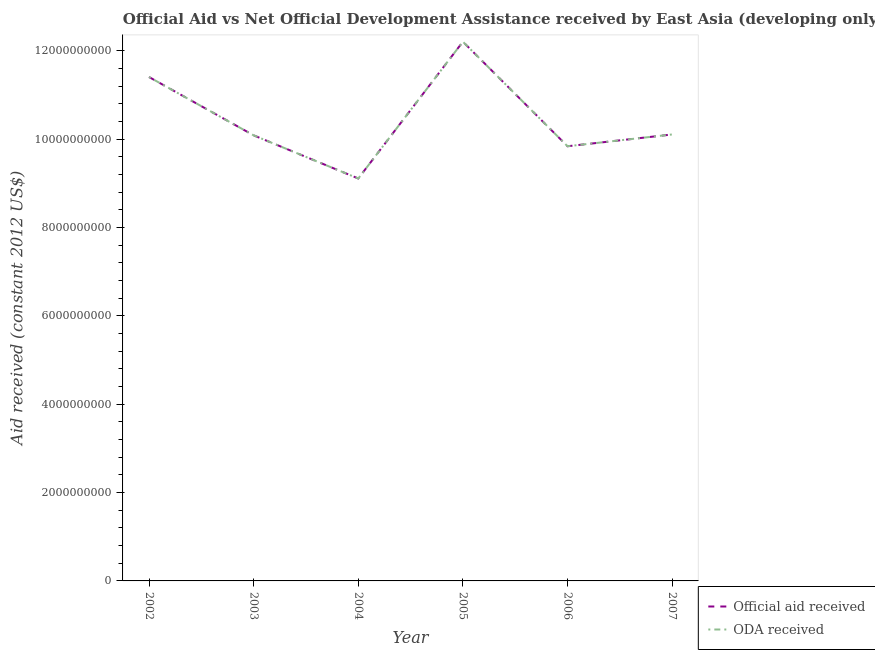How many different coloured lines are there?
Offer a terse response. 2. What is the oda received in 2005?
Ensure brevity in your answer.  1.22e+1. Across all years, what is the maximum official aid received?
Offer a terse response. 1.22e+1. Across all years, what is the minimum oda received?
Make the answer very short. 9.11e+09. What is the total oda received in the graph?
Provide a short and direct response. 6.28e+1. What is the difference between the oda received in 2004 and that in 2007?
Provide a succinct answer. -9.97e+08. What is the difference between the official aid received in 2003 and the oda received in 2004?
Make the answer very short. 9.77e+08. What is the average oda received per year?
Provide a short and direct response. 1.05e+1. In the year 2003, what is the difference between the oda received and official aid received?
Give a very brief answer. 0. What is the ratio of the official aid received in 2005 to that in 2007?
Ensure brevity in your answer.  1.21. Is the difference between the official aid received in 2003 and 2007 greater than the difference between the oda received in 2003 and 2007?
Offer a very short reply. No. What is the difference between the highest and the second highest oda received?
Provide a succinct answer. 7.99e+08. What is the difference between the highest and the lowest oda received?
Provide a succinct answer. 3.10e+09. In how many years, is the oda received greater than the average oda received taken over all years?
Your response must be concise. 2. Is the sum of the official aid received in 2003 and 2004 greater than the maximum oda received across all years?
Make the answer very short. Yes. Is the official aid received strictly greater than the oda received over the years?
Your answer should be very brief. No. How many years are there in the graph?
Ensure brevity in your answer.  6. Are the values on the major ticks of Y-axis written in scientific E-notation?
Your answer should be compact. No. Does the graph contain any zero values?
Make the answer very short. No. Does the graph contain grids?
Provide a succinct answer. No. How are the legend labels stacked?
Your response must be concise. Vertical. What is the title of the graph?
Your answer should be very brief. Official Aid vs Net Official Development Assistance received by East Asia (developing only) . Does "Lower secondary rate" appear as one of the legend labels in the graph?
Give a very brief answer. No. What is the label or title of the Y-axis?
Ensure brevity in your answer.  Aid received (constant 2012 US$). What is the Aid received (constant 2012 US$) of Official aid received in 2002?
Make the answer very short. 1.14e+1. What is the Aid received (constant 2012 US$) in ODA received in 2002?
Ensure brevity in your answer.  1.14e+1. What is the Aid received (constant 2012 US$) of Official aid received in 2003?
Your answer should be very brief. 1.01e+1. What is the Aid received (constant 2012 US$) in ODA received in 2003?
Offer a very short reply. 1.01e+1. What is the Aid received (constant 2012 US$) in Official aid received in 2004?
Provide a succinct answer. 9.11e+09. What is the Aid received (constant 2012 US$) of ODA received in 2004?
Your response must be concise. 9.11e+09. What is the Aid received (constant 2012 US$) in Official aid received in 2005?
Make the answer very short. 1.22e+1. What is the Aid received (constant 2012 US$) of ODA received in 2005?
Offer a very short reply. 1.22e+1. What is the Aid received (constant 2012 US$) of Official aid received in 2006?
Give a very brief answer. 9.84e+09. What is the Aid received (constant 2012 US$) of ODA received in 2006?
Provide a succinct answer. 9.84e+09. What is the Aid received (constant 2012 US$) in Official aid received in 2007?
Offer a terse response. 1.01e+1. What is the Aid received (constant 2012 US$) in ODA received in 2007?
Offer a terse response. 1.01e+1. Across all years, what is the maximum Aid received (constant 2012 US$) of Official aid received?
Ensure brevity in your answer.  1.22e+1. Across all years, what is the maximum Aid received (constant 2012 US$) of ODA received?
Offer a terse response. 1.22e+1. Across all years, what is the minimum Aid received (constant 2012 US$) in Official aid received?
Ensure brevity in your answer.  9.11e+09. Across all years, what is the minimum Aid received (constant 2012 US$) of ODA received?
Ensure brevity in your answer.  9.11e+09. What is the total Aid received (constant 2012 US$) of Official aid received in the graph?
Your answer should be compact. 6.28e+1. What is the total Aid received (constant 2012 US$) of ODA received in the graph?
Your response must be concise. 6.28e+1. What is the difference between the Aid received (constant 2012 US$) of Official aid received in 2002 and that in 2003?
Ensure brevity in your answer.  1.32e+09. What is the difference between the Aid received (constant 2012 US$) of ODA received in 2002 and that in 2003?
Provide a succinct answer. 1.32e+09. What is the difference between the Aid received (constant 2012 US$) of Official aid received in 2002 and that in 2004?
Give a very brief answer. 2.30e+09. What is the difference between the Aid received (constant 2012 US$) of ODA received in 2002 and that in 2004?
Provide a short and direct response. 2.30e+09. What is the difference between the Aid received (constant 2012 US$) of Official aid received in 2002 and that in 2005?
Your answer should be very brief. -7.99e+08. What is the difference between the Aid received (constant 2012 US$) in ODA received in 2002 and that in 2005?
Ensure brevity in your answer.  -7.99e+08. What is the difference between the Aid received (constant 2012 US$) of Official aid received in 2002 and that in 2006?
Give a very brief answer. 1.57e+09. What is the difference between the Aid received (constant 2012 US$) of ODA received in 2002 and that in 2006?
Your answer should be compact. 1.57e+09. What is the difference between the Aid received (constant 2012 US$) of Official aid received in 2002 and that in 2007?
Ensure brevity in your answer.  1.30e+09. What is the difference between the Aid received (constant 2012 US$) of ODA received in 2002 and that in 2007?
Provide a succinct answer. 1.30e+09. What is the difference between the Aid received (constant 2012 US$) in Official aid received in 2003 and that in 2004?
Ensure brevity in your answer.  9.77e+08. What is the difference between the Aid received (constant 2012 US$) of ODA received in 2003 and that in 2004?
Keep it short and to the point. 9.77e+08. What is the difference between the Aid received (constant 2012 US$) in Official aid received in 2003 and that in 2005?
Your answer should be compact. -2.12e+09. What is the difference between the Aid received (constant 2012 US$) of ODA received in 2003 and that in 2005?
Provide a succinct answer. -2.12e+09. What is the difference between the Aid received (constant 2012 US$) of Official aid received in 2003 and that in 2006?
Make the answer very short. 2.47e+08. What is the difference between the Aid received (constant 2012 US$) of ODA received in 2003 and that in 2006?
Your answer should be very brief. 2.47e+08. What is the difference between the Aid received (constant 2012 US$) in Official aid received in 2003 and that in 2007?
Keep it short and to the point. -2.01e+07. What is the difference between the Aid received (constant 2012 US$) in ODA received in 2003 and that in 2007?
Provide a succinct answer. -2.01e+07. What is the difference between the Aid received (constant 2012 US$) in Official aid received in 2004 and that in 2005?
Keep it short and to the point. -3.10e+09. What is the difference between the Aid received (constant 2012 US$) of ODA received in 2004 and that in 2005?
Your answer should be compact. -3.10e+09. What is the difference between the Aid received (constant 2012 US$) of Official aid received in 2004 and that in 2006?
Offer a very short reply. -7.30e+08. What is the difference between the Aid received (constant 2012 US$) in ODA received in 2004 and that in 2006?
Offer a very short reply. -7.30e+08. What is the difference between the Aid received (constant 2012 US$) of Official aid received in 2004 and that in 2007?
Give a very brief answer. -9.97e+08. What is the difference between the Aid received (constant 2012 US$) in ODA received in 2004 and that in 2007?
Your answer should be very brief. -9.97e+08. What is the difference between the Aid received (constant 2012 US$) of Official aid received in 2005 and that in 2006?
Offer a very short reply. 2.37e+09. What is the difference between the Aid received (constant 2012 US$) of ODA received in 2005 and that in 2006?
Offer a very short reply. 2.37e+09. What is the difference between the Aid received (constant 2012 US$) of Official aid received in 2005 and that in 2007?
Provide a succinct answer. 2.10e+09. What is the difference between the Aid received (constant 2012 US$) of ODA received in 2005 and that in 2007?
Your response must be concise. 2.10e+09. What is the difference between the Aid received (constant 2012 US$) of Official aid received in 2006 and that in 2007?
Offer a very short reply. -2.67e+08. What is the difference between the Aid received (constant 2012 US$) in ODA received in 2006 and that in 2007?
Make the answer very short. -2.67e+08. What is the difference between the Aid received (constant 2012 US$) of Official aid received in 2002 and the Aid received (constant 2012 US$) of ODA received in 2003?
Your answer should be very brief. 1.32e+09. What is the difference between the Aid received (constant 2012 US$) in Official aid received in 2002 and the Aid received (constant 2012 US$) in ODA received in 2004?
Keep it short and to the point. 2.30e+09. What is the difference between the Aid received (constant 2012 US$) in Official aid received in 2002 and the Aid received (constant 2012 US$) in ODA received in 2005?
Your answer should be compact. -7.99e+08. What is the difference between the Aid received (constant 2012 US$) in Official aid received in 2002 and the Aid received (constant 2012 US$) in ODA received in 2006?
Offer a terse response. 1.57e+09. What is the difference between the Aid received (constant 2012 US$) in Official aid received in 2002 and the Aid received (constant 2012 US$) in ODA received in 2007?
Keep it short and to the point. 1.30e+09. What is the difference between the Aid received (constant 2012 US$) in Official aid received in 2003 and the Aid received (constant 2012 US$) in ODA received in 2004?
Your response must be concise. 9.77e+08. What is the difference between the Aid received (constant 2012 US$) of Official aid received in 2003 and the Aid received (constant 2012 US$) of ODA received in 2005?
Offer a very short reply. -2.12e+09. What is the difference between the Aid received (constant 2012 US$) in Official aid received in 2003 and the Aid received (constant 2012 US$) in ODA received in 2006?
Offer a terse response. 2.47e+08. What is the difference between the Aid received (constant 2012 US$) of Official aid received in 2003 and the Aid received (constant 2012 US$) of ODA received in 2007?
Your response must be concise. -2.01e+07. What is the difference between the Aid received (constant 2012 US$) in Official aid received in 2004 and the Aid received (constant 2012 US$) in ODA received in 2005?
Provide a succinct answer. -3.10e+09. What is the difference between the Aid received (constant 2012 US$) of Official aid received in 2004 and the Aid received (constant 2012 US$) of ODA received in 2006?
Give a very brief answer. -7.30e+08. What is the difference between the Aid received (constant 2012 US$) of Official aid received in 2004 and the Aid received (constant 2012 US$) of ODA received in 2007?
Provide a short and direct response. -9.97e+08. What is the difference between the Aid received (constant 2012 US$) in Official aid received in 2005 and the Aid received (constant 2012 US$) in ODA received in 2006?
Give a very brief answer. 2.37e+09. What is the difference between the Aid received (constant 2012 US$) in Official aid received in 2005 and the Aid received (constant 2012 US$) in ODA received in 2007?
Give a very brief answer. 2.10e+09. What is the difference between the Aid received (constant 2012 US$) of Official aid received in 2006 and the Aid received (constant 2012 US$) of ODA received in 2007?
Your answer should be very brief. -2.67e+08. What is the average Aid received (constant 2012 US$) in Official aid received per year?
Your answer should be very brief. 1.05e+1. What is the average Aid received (constant 2012 US$) in ODA received per year?
Your response must be concise. 1.05e+1. In the year 2004, what is the difference between the Aid received (constant 2012 US$) of Official aid received and Aid received (constant 2012 US$) of ODA received?
Your response must be concise. 0. In the year 2005, what is the difference between the Aid received (constant 2012 US$) in Official aid received and Aid received (constant 2012 US$) in ODA received?
Your answer should be compact. 0. In the year 2006, what is the difference between the Aid received (constant 2012 US$) in Official aid received and Aid received (constant 2012 US$) in ODA received?
Your answer should be very brief. 0. In the year 2007, what is the difference between the Aid received (constant 2012 US$) of Official aid received and Aid received (constant 2012 US$) of ODA received?
Offer a very short reply. 0. What is the ratio of the Aid received (constant 2012 US$) in Official aid received in 2002 to that in 2003?
Provide a short and direct response. 1.13. What is the ratio of the Aid received (constant 2012 US$) in ODA received in 2002 to that in 2003?
Keep it short and to the point. 1.13. What is the ratio of the Aid received (constant 2012 US$) in Official aid received in 2002 to that in 2004?
Ensure brevity in your answer.  1.25. What is the ratio of the Aid received (constant 2012 US$) in ODA received in 2002 to that in 2004?
Make the answer very short. 1.25. What is the ratio of the Aid received (constant 2012 US$) in Official aid received in 2002 to that in 2005?
Provide a short and direct response. 0.93. What is the ratio of the Aid received (constant 2012 US$) of ODA received in 2002 to that in 2005?
Provide a short and direct response. 0.93. What is the ratio of the Aid received (constant 2012 US$) in Official aid received in 2002 to that in 2006?
Provide a succinct answer. 1.16. What is the ratio of the Aid received (constant 2012 US$) of ODA received in 2002 to that in 2006?
Provide a succinct answer. 1.16. What is the ratio of the Aid received (constant 2012 US$) in Official aid received in 2002 to that in 2007?
Your answer should be very brief. 1.13. What is the ratio of the Aid received (constant 2012 US$) of ODA received in 2002 to that in 2007?
Your response must be concise. 1.13. What is the ratio of the Aid received (constant 2012 US$) of Official aid received in 2003 to that in 2004?
Give a very brief answer. 1.11. What is the ratio of the Aid received (constant 2012 US$) of ODA received in 2003 to that in 2004?
Your response must be concise. 1.11. What is the ratio of the Aid received (constant 2012 US$) in Official aid received in 2003 to that in 2005?
Ensure brevity in your answer.  0.83. What is the ratio of the Aid received (constant 2012 US$) of ODA received in 2003 to that in 2005?
Offer a terse response. 0.83. What is the ratio of the Aid received (constant 2012 US$) in Official aid received in 2003 to that in 2006?
Keep it short and to the point. 1.03. What is the ratio of the Aid received (constant 2012 US$) in ODA received in 2003 to that in 2006?
Keep it short and to the point. 1.03. What is the ratio of the Aid received (constant 2012 US$) in ODA received in 2003 to that in 2007?
Provide a succinct answer. 1. What is the ratio of the Aid received (constant 2012 US$) in Official aid received in 2004 to that in 2005?
Provide a short and direct response. 0.75. What is the ratio of the Aid received (constant 2012 US$) of ODA received in 2004 to that in 2005?
Ensure brevity in your answer.  0.75. What is the ratio of the Aid received (constant 2012 US$) of Official aid received in 2004 to that in 2006?
Offer a very short reply. 0.93. What is the ratio of the Aid received (constant 2012 US$) in ODA received in 2004 to that in 2006?
Provide a short and direct response. 0.93. What is the ratio of the Aid received (constant 2012 US$) in Official aid received in 2004 to that in 2007?
Make the answer very short. 0.9. What is the ratio of the Aid received (constant 2012 US$) in ODA received in 2004 to that in 2007?
Your answer should be compact. 0.9. What is the ratio of the Aid received (constant 2012 US$) in Official aid received in 2005 to that in 2006?
Provide a succinct answer. 1.24. What is the ratio of the Aid received (constant 2012 US$) in ODA received in 2005 to that in 2006?
Keep it short and to the point. 1.24. What is the ratio of the Aid received (constant 2012 US$) of Official aid received in 2005 to that in 2007?
Your response must be concise. 1.21. What is the ratio of the Aid received (constant 2012 US$) of ODA received in 2005 to that in 2007?
Your answer should be compact. 1.21. What is the ratio of the Aid received (constant 2012 US$) of Official aid received in 2006 to that in 2007?
Provide a succinct answer. 0.97. What is the ratio of the Aid received (constant 2012 US$) in ODA received in 2006 to that in 2007?
Provide a succinct answer. 0.97. What is the difference between the highest and the second highest Aid received (constant 2012 US$) in Official aid received?
Your answer should be very brief. 7.99e+08. What is the difference between the highest and the second highest Aid received (constant 2012 US$) of ODA received?
Provide a short and direct response. 7.99e+08. What is the difference between the highest and the lowest Aid received (constant 2012 US$) in Official aid received?
Make the answer very short. 3.10e+09. What is the difference between the highest and the lowest Aid received (constant 2012 US$) of ODA received?
Your answer should be very brief. 3.10e+09. 